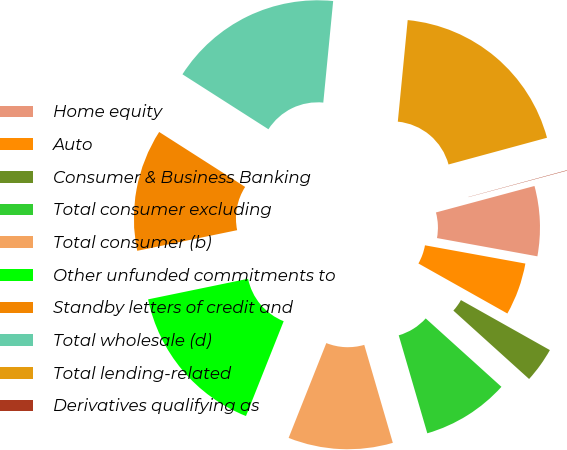Convert chart. <chart><loc_0><loc_0><loc_500><loc_500><pie_chart><fcel>Home equity<fcel>Auto<fcel>Consumer & Business Banking<fcel>Total consumer excluding<fcel>Total consumer (b)<fcel>Other unfunded commitments to<fcel>Standby letters of credit and<fcel>Total wholesale (d)<fcel>Total lending-related<fcel>Derivatives qualifying as<nl><fcel>7.04%<fcel>5.29%<fcel>3.54%<fcel>8.79%<fcel>10.54%<fcel>15.74%<fcel>12.29%<fcel>17.49%<fcel>19.24%<fcel>0.04%<nl></chart> 